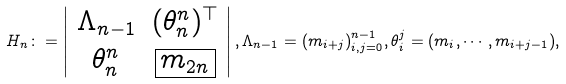<formula> <loc_0><loc_0><loc_500><loc_500>H _ { n } \colon = \left | \begin{array} { c c } \Lambda _ { n - 1 } & ( \theta _ { n } ^ { n } ) ^ { \top } \\ \theta _ { n } ^ { n } & \boxed { m _ { 2 n } } \end{array} \right | , \Lambda _ { n - 1 } = ( m _ { i + j } ) _ { i , j = 0 } ^ { n - 1 } , \theta _ { i } ^ { j } = ( m _ { i } , \cdots , m _ { i + j - 1 } ) ,</formula> 